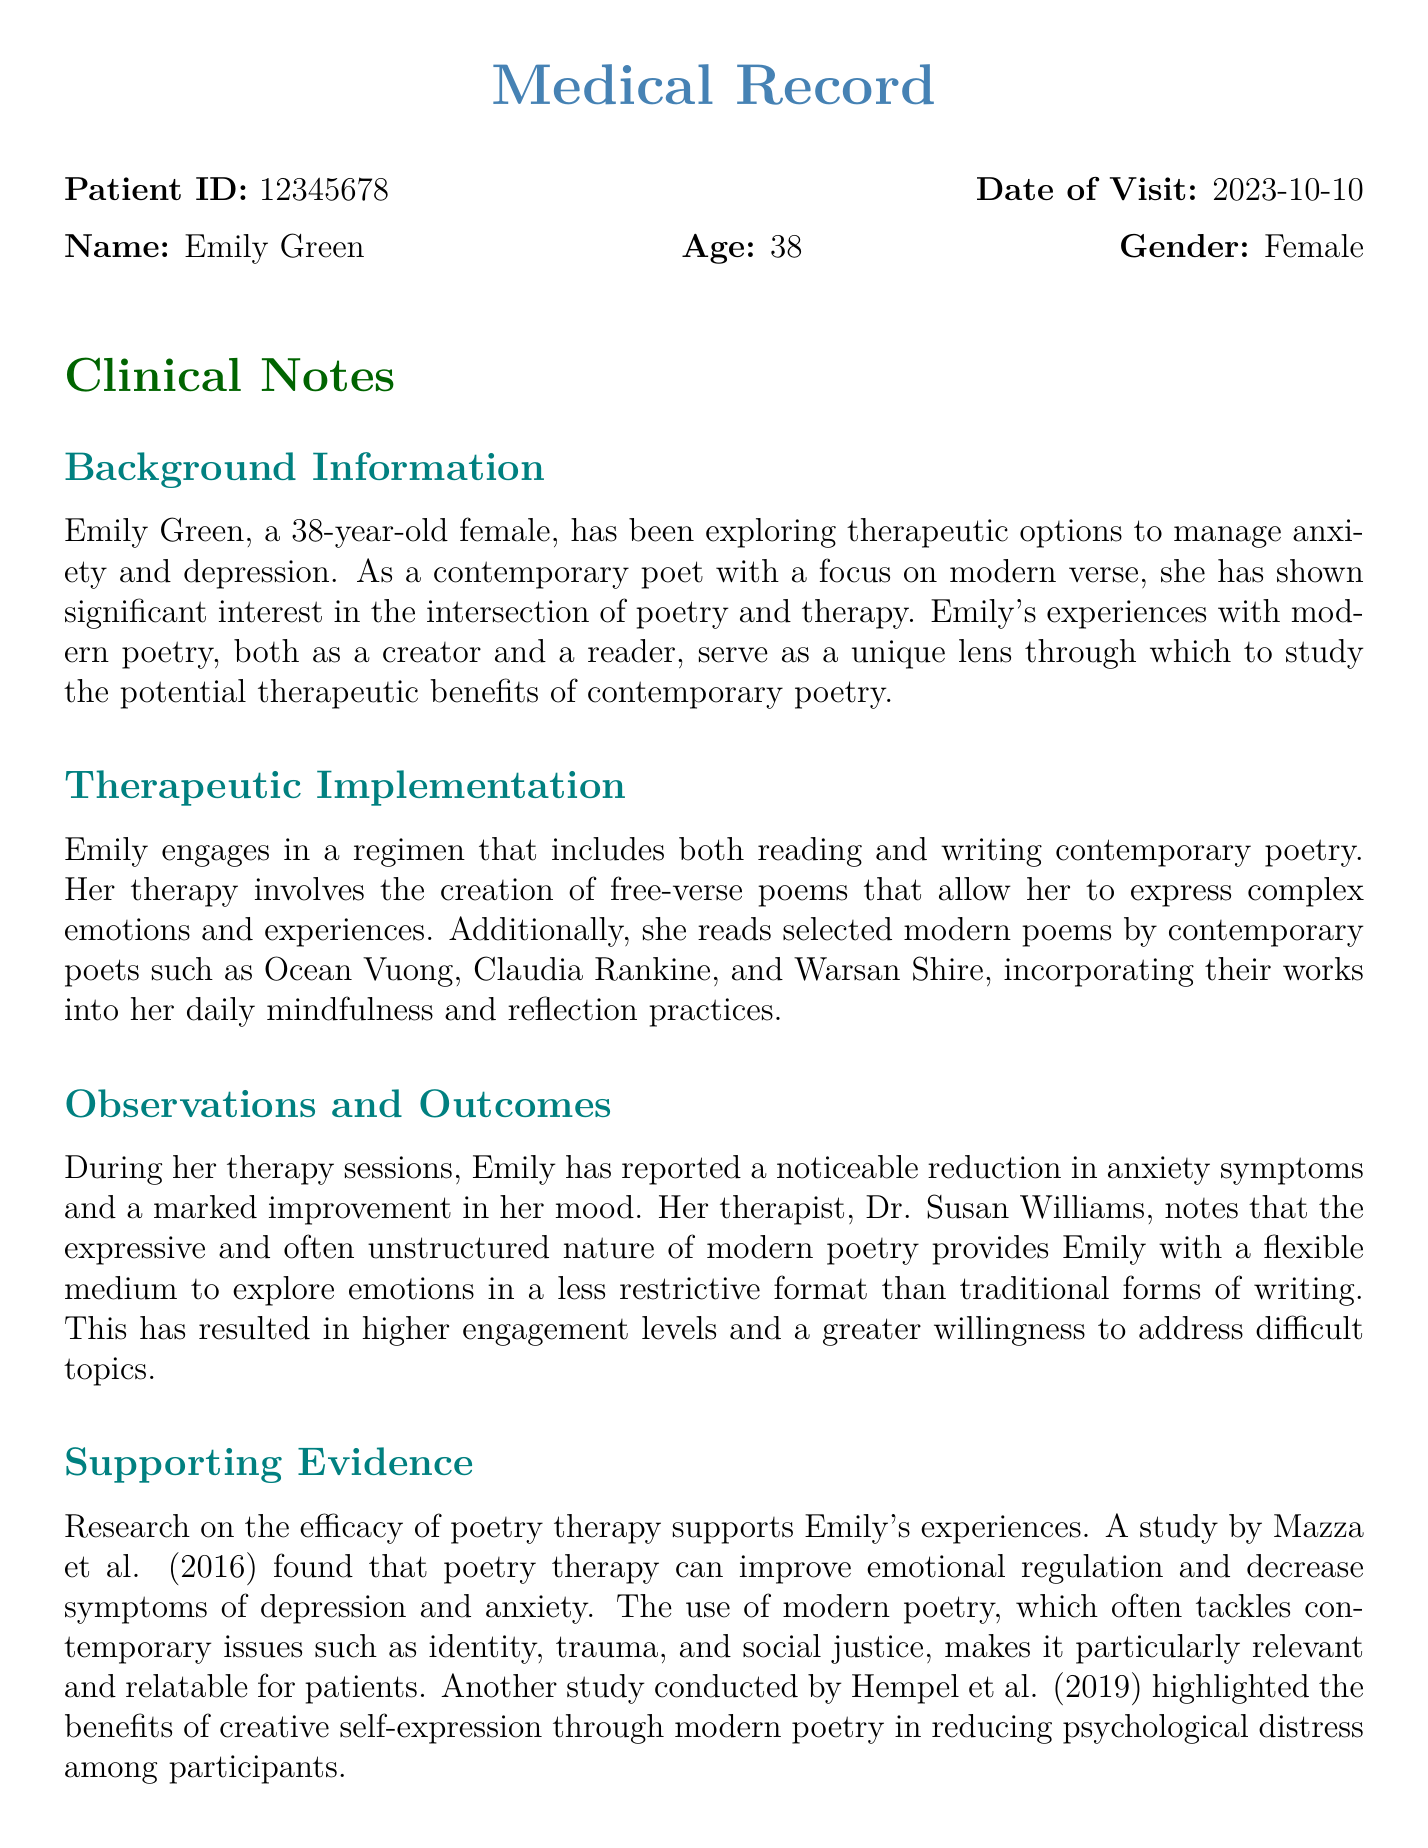what is the patient ID? The patient ID is listed at the top of the document under the patient details section.
Answer: 12345678 what is the date of visit? The date of visit is specified immediately following the patient ID in the clinical notes.
Answer: 2023-10-10 who is the therapist? The therapist's name is mentioned in the observations and outcomes section.
Answer: Dr. Susan Williams what type of poetry does Emily focus on? The type of poetry Emily engages with is noted in the therapeutic implementation section.
Answer: Contemporary poetry which poets are mentioned in the document? The poets who are incorporated into Emily's practices are listed in the therapeutic implementation section.
Answer: Ocean Vuong, Claudia Rankine, Warsan Shire how has Emily's mood changed? Changes in Emily's mood are noted under observations and outcomes, indicating her progress.
Answer: Marked improvement what are the recommended next steps for Emily? The next steps for Emily are outlined in the recommendations section of the document.
Answer: Continue current regimen and incorporate group poetry sessions what studies are referenced in the document? The studies supporting the therapeutic benefits of poetry therapy are cited in the supporting evidence section.
Answer: Mazza et al. (2016), Hempel et al. (2019) what is the age of the patient? The patient's age is stated at the beginning of the clinical notes.
Answer: 38 